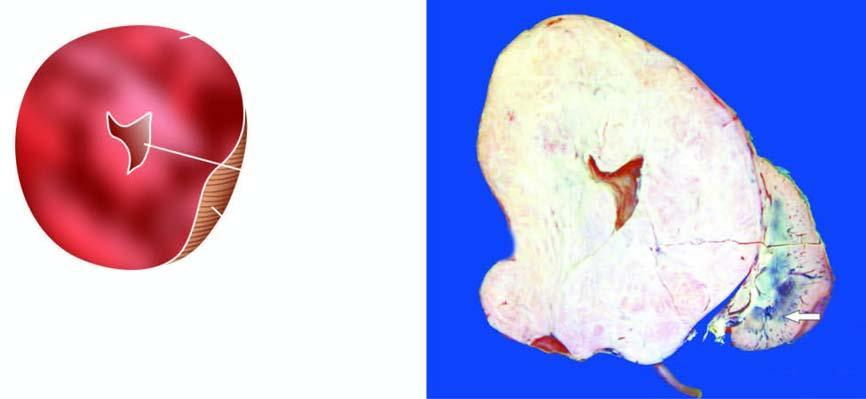does the tubular lumina cont ain show replacement of almost whole kidney by the tumour leaving a thin strip of compressed renal tissue at lower end arrow?
Answer the question using a single word or phrase. No 